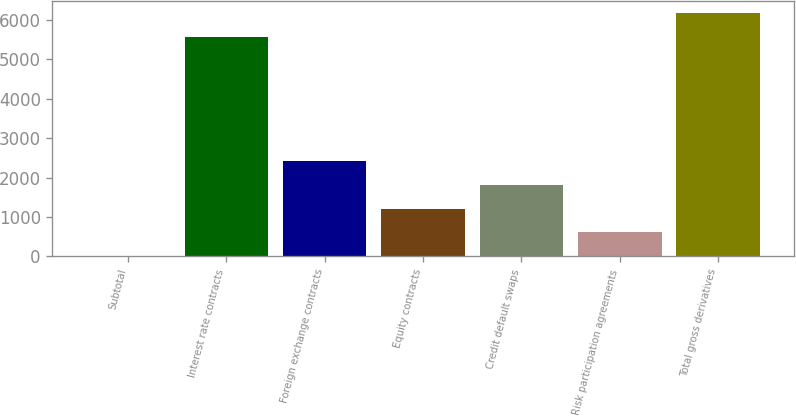Convert chart to OTSL. <chart><loc_0><loc_0><loc_500><loc_500><bar_chart><fcel>Subtotal<fcel>Interest rate contracts<fcel>Foreign exchange contracts<fcel>Equity contracts<fcel>Credit default swaps<fcel>Risk participation agreements<fcel>Total gross derivatives<nl><fcel>1<fcel>5573<fcel>2423.8<fcel>1212.4<fcel>1818.1<fcel>606.7<fcel>6178.7<nl></chart> 